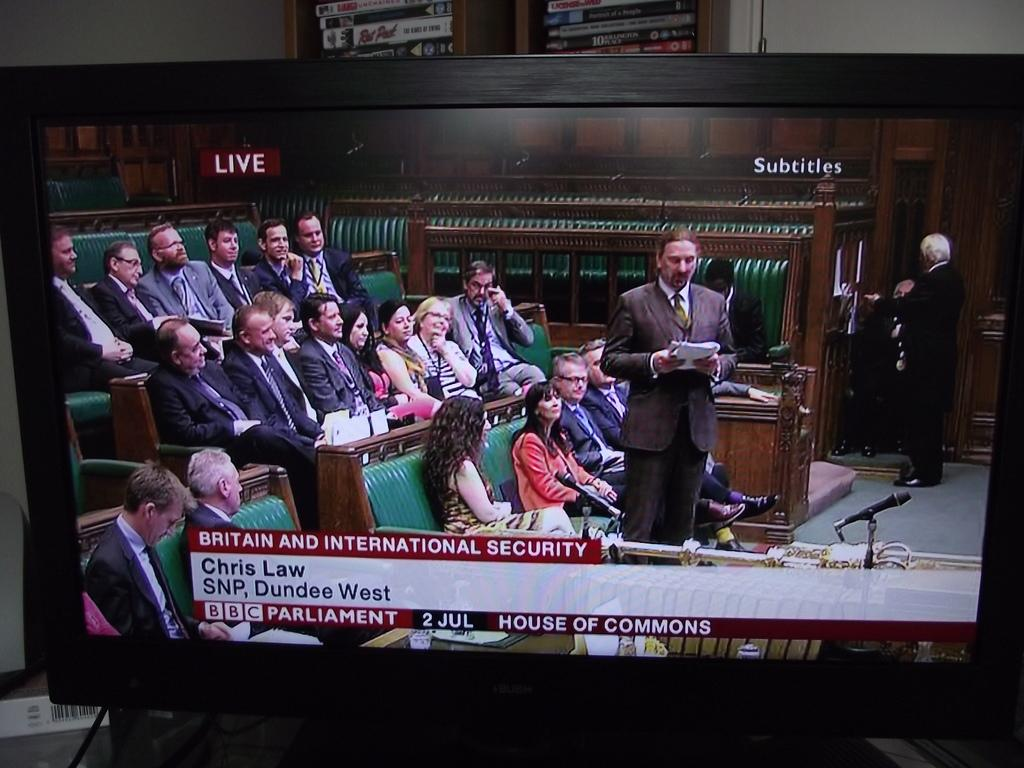<image>
Share a concise interpretation of the image provided. A computer monitor displays the Britain and International Security meeting with a man standing reading from docuements. 